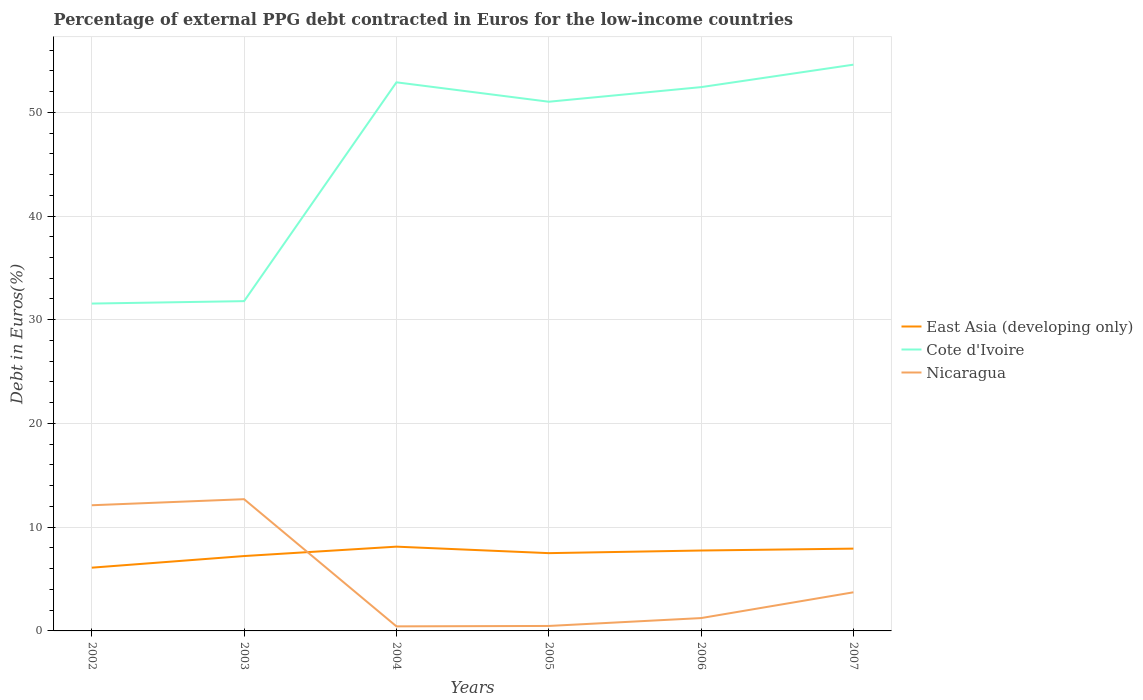Across all years, what is the maximum percentage of external PPG debt contracted in Euros in East Asia (developing only)?
Make the answer very short. 6.1. In which year was the percentage of external PPG debt contracted in Euros in Nicaragua maximum?
Make the answer very short. 2004. What is the total percentage of external PPG debt contracted in Euros in East Asia (developing only) in the graph?
Offer a very short reply. -2.03. What is the difference between the highest and the second highest percentage of external PPG debt contracted in Euros in East Asia (developing only)?
Your response must be concise. 2.03. What is the difference between the highest and the lowest percentage of external PPG debt contracted in Euros in East Asia (developing only)?
Offer a very short reply. 4. What is the difference between two consecutive major ticks on the Y-axis?
Offer a very short reply. 10. Does the graph contain any zero values?
Your answer should be compact. No. Does the graph contain grids?
Offer a very short reply. Yes. How are the legend labels stacked?
Give a very brief answer. Vertical. What is the title of the graph?
Offer a terse response. Percentage of external PPG debt contracted in Euros for the low-income countries. Does "Guinea-Bissau" appear as one of the legend labels in the graph?
Your response must be concise. No. What is the label or title of the X-axis?
Give a very brief answer. Years. What is the label or title of the Y-axis?
Your answer should be compact. Debt in Euros(%). What is the Debt in Euros(%) in East Asia (developing only) in 2002?
Offer a terse response. 6.1. What is the Debt in Euros(%) of Cote d'Ivoire in 2002?
Offer a terse response. 31.56. What is the Debt in Euros(%) of Nicaragua in 2002?
Provide a short and direct response. 12.12. What is the Debt in Euros(%) in East Asia (developing only) in 2003?
Your answer should be compact. 7.22. What is the Debt in Euros(%) of Cote d'Ivoire in 2003?
Offer a terse response. 31.79. What is the Debt in Euros(%) of Nicaragua in 2003?
Offer a terse response. 12.7. What is the Debt in Euros(%) of East Asia (developing only) in 2004?
Give a very brief answer. 8.12. What is the Debt in Euros(%) of Cote d'Ivoire in 2004?
Provide a succinct answer. 52.89. What is the Debt in Euros(%) in Nicaragua in 2004?
Your response must be concise. 0.44. What is the Debt in Euros(%) of East Asia (developing only) in 2005?
Provide a succinct answer. 7.5. What is the Debt in Euros(%) of Cote d'Ivoire in 2005?
Keep it short and to the point. 51.02. What is the Debt in Euros(%) of Nicaragua in 2005?
Offer a very short reply. 0.48. What is the Debt in Euros(%) in East Asia (developing only) in 2006?
Provide a succinct answer. 7.75. What is the Debt in Euros(%) in Cote d'Ivoire in 2006?
Offer a terse response. 52.42. What is the Debt in Euros(%) in Nicaragua in 2006?
Offer a very short reply. 1.24. What is the Debt in Euros(%) of East Asia (developing only) in 2007?
Your answer should be compact. 7.93. What is the Debt in Euros(%) in Cote d'Ivoire in 2007?
Your answer should be compact. 54.59. What is the Debt in Euros(%) in Nicaragua in 2007?
Offer a terse response. 3.72. Across all years, what is the maximum Debt in Euros(%) of East Asia (developing only)?
Provide a short and direct response. 8.12. Across all years, what is the maximum Debt in Euros(%) in Cote d'Ivoire?
Offer a very short reply. 54.59. Across all years, what is the maximum Debt in Euros(%) of Nicaragua?
Keep it short and to the point. 12.7. Across all years, what is the minimum Debt in Euros(%) of East Asia (developing only)?
Provide a short and direct response. 6.1. Across all years, what is the minimum Debt in Euros(%) of Cote d'Ivoire?
Make the answer very short. 31.56. Across all years, what is the minimum Debt in Euros(%) of Nicaragua?
Offer a terse response. 0.44. What is the total Debt in Euros(%) in East Asia (developing only) in the graph?
Give a very brief answer. 44.62. What is the total Debt in Euros(%) of Cote d'Ivoire in the graph?
Ensure brevity in your answer.  274.27. What is the total Debt in Euros(%) in Nicaragua in the graph?
Provide a short and direct response. 30.7. What is the difference between the Debt in Euros(%) of East Asia (developing only) in 2002 and that in 2003?
Your answer should be compact. -1.12. What is the difference between the Debt in Euros(%) of Cote d'Ivoire in 2002 and that in 2003?
Give a very brief answer. -0.23. What is the difference between the Debt in Euros(%) in Nicaragua in 2002 and that in 2003?
Your answer should be compact. -0.58. What is the difference between the Debt in Euros(%) in East Asia (developing only) in 2002 and that in 2004?
Provide a succinct answer. -2.03. What is the difference between the Debt in Euros(%) in Cote d'Ivoire in 2002 and that in 2004?
Keep it short and to the point. -21.33. What is the difference between the Debt in Euros(%) in Nicaragua in 2002 and that in 2004?
Provide a succinct answer. 11.68. What is the difference between the Debt in Euros(%) of East Asia (developing only) in 2002 and that in 2005?
Ensure brevity in your answer.  -1.4. What is the difference between the Debt in Euros(%) in Cote d'Ivoire in 2002 and that in 2005?
Offer a very short reply. -19.46. What is the difference between the Debt in Euros(%) of Nicaragua in 2002 and that in 2005?
Offer a terse response. 11.64. What is the difference between the Debt in Euros(%) of East Asia (developing only) in 2002 and that in 2006?
Provide a succinct answer. -1.65. What is the difference between the Debt in Euros(%) in Cote d'Ivoire in 2002 and that in 2006?
Ensure brevity in your answer.  -20.87. What is the difference between the Debt in Euros(%) of Nicaragua in 2002 and that in 2006?
Keep it short and to the point. 10.88. What is the difference between the Debt in Euros(%) in East Asia (developing only) in 2002 and that in 2007?
Your answer should be very brief. -1.84. What is the difference between the Debt in Euros(%) in Cote d'Ivoire in 2002 and that in 2007?
Offer a very short reply. -23.03. What is the difference between the Debt in Euros(%) of Nicaragua in 2002 and that in 2007?
Keep it short and to the point. 8.39. What is the difference between the Debt in Euros(%) in East Asia (developing only) in 2003 and that in 2004?
Your answer should be very brief. -0.91. What is the difference between the Debt in Euros(%) in Cote d'Ivoire in 2003 and that in 2004?
Make the answer very short. -21.09. What is the difference between the Debt in Euros(%) of Nicaragua in 2003 and that in 2004?
Your answer should be very brief. 12.26. What is the difference between the Debt in Euros(%) of East Asia (developing only) in 2003 and that in 2005?
Provide a succinct answer. -0.28. What is the difference between the Debt in Euros(%) of Cote d'Ivoire in 2003 and that in 2005?
Provide a succinct answer. -19.22. What is the difference between the Debt in Euros(%) in Nicaragua in 2003 and that in 2005?
Your response must be concise. 12.22. What is the difference between the Debt in Euros(%) in East Asia (developing only) in 2003 and that in 2006?
Your answer should be compact. -0.53. What is the difference between the Debt in Euros(%) of Cote d'Ivoire in 2003 and that in 2006?
Offer a terse response. -20.63. What is the difference between the Debt in Euros(%) in Nicaragua in 2003 and that in 2006?
Keep it short and to the point. 11.46. What is the difference between the Debt in Euros(%) of East Asia (developing only) in 2003 and that in 2007?
Your answer should be very brief. -0.71. What is the difference between the Debt in Euros(%) in Cote d'Ivoire in 2003 and that in 2007?
Your answer should be compact. -22.8. What is the difference between the Debt in Euros(%) in Nicaragua in 2003 and that in 2007?
Your answer should be very brief. 8.98. What is the difference between the Debt in Euros(%) in East Asia (developing only) in 2004 and that in 2005?
Provide a succinct answer. 0.63. What is the difference between the Debt in Euros(%) in Cote d'Ivoire in 2004 and that in 2005?
Keep it short and to the point. 1.87. What is the difference between the Debt in Euros(%) of Nicaragua in 2004 and that in 2005?
Keep it short and to the point. -0.04. What is the difference between the Debt in Euros(%) in East Asia (developing only) in 2004 and that in 2006?
Provide a succinct answer. 0.37. What is the difference between the Debt in Euros(%) in Cote d'Ivoire in 2004 and that in 2006?
Your response must be concise. 0.46. What is the difference between the Debt in Euros(%) in Nicaragua in 2004 and that in 2006?
Keep it short and to the point. -0.8. What is the difference between the Debt in Euros(%) of East Asia (developing only) in 2004 and that in 2007?
Make the answer very short. 0.19. What is the difference between the Debt in Euros(%) of Cote d'Ivoire in 2004 and that in 2007?
Give a very brief answer. -1.7. What is the difference between the Debt in Euros(%) of Nicaragua in 2004 and that in 2007?
Your answer should be very brief. -3.28. What is the difference between the Debt in Euros(%) in East Asia (developing only) in 2005 and that in 2006?
Ensure brevity in your answer.  -0.25. What is the difference between the Debt in Euros(%) of Cote d'Ivoire in 2005 and that in 2006?
Offer a very short reply. -1.41. What is the difference between the Debt in Euros(%) of Nicaragua in 2005 and that in 2006?
Your answer should be compact. -0.76. What is the difference between the Debt in Euros(%) of East Asia (developing only) in 2005 and that in 2007?
Keep it short and to the point. -0.44. What is the difference between the Debt in Euros(%) in Cote d'Ivoire in 2005 and that in 2007?
Your answer should be very brief. -3.57. What is the difference between the Debt in Euros(%) of Nicaragua in 2005 and that in 2007?
Make the answer very short. -3.24. What is the difference between the Debt in Euros(%) of East Asia (developing only) in 2006 and that in 2007?
Ensure brevity in your answer.  -0.18. What is the difference between the Debt in Euros(%) of Cote d'Ivoire in 2006 and that in 2007?
Provide a short and direct response. -2.17. What is the difference between the Debt in Euros(%) of Nicaragua in 2006 and that in 2007?
Offer a terse response. -2.49. What is the difference between the Debt in Euros(%) in East Asia (developing only) in 2002 and the Debt in Euros(%) in Cote d'Ivoire in 2003?
Ensure brevity in your answer.  -25.69. What is the difference between the Debt in Euros(%) of East Asia (developing only) in 2002 and the Debt in Euros(%) of Nicaragua in 2003?
Provide a succinct answer. -6.6. What is the difference between the Debt in Euros(%) in Cote d'Ivoire in 2002 and the Debt in Euros(%) in Nicaragua in 2003?
Make the answer very short. 18.86. What is the difference between the Debt in Euros(%) in East Asia (developing only) in 2002 and the Debt in Euros(%) in Cote d'Ivoire in 2004?
Provide a short and direct response. -46.79. What is the difference between the Debt in Euros(%) in East Asia (developing only) in 2002 and the Debt in Euros(%) in Nicaragua in 2004?
Your answer should be very brief. 5.66. What is the difference between the Debt in Euros(%) in Cote d'Ivoire in 2002 and the Debt in Euros(%) in Nicaragua in 2004?
Provide a short and direct response. 31.12. What is the difference between the Debt in Euros(%) of East Asia (developing only) in 2002 and the Debt in Euros(%) of Cote d'Ivoire in 2005?
Provide a succinct answer. -44.92. What is the difference between the Debt in Euros(%) of East Asia (developing only) in 2002 and the Debt in Euros(%) of Nicaragua in 2005?
Your response must be concise. 5.62. What is the difference between the Debt in Euros(%) in Cote d'Ivoire in 2002 and the Debt in Euros(%) in Nicaragua in 2005?
Provide a short and direct response. 31.08. What is the difference between the Debt in Euros(%) of East Asia (developing only) in 2002 and the Debt in Euros(%) of Cote d'Ivoire in 2006?
Your response must be concise. -46.33. What is the difference between the Debt in Euros(%) of East Asia (developing only) in 2002 and the Debt in Euros(%) of Nicaragua in 2006?
Offer a terse response. 4.86. What is the difference between the Debt in Euros(%) of Cote d'Ivoire in 2002 and the Debt in Euros(%) of Nicaragua in 2006?
Provide a succinct answer. 30.32. What is the difference between the Debt in Euros(%) of East Asia (developing only) in 2002 and the Debt in Euros(%) of Cote d'Ivoire in 2007?
Keep it short and to the point. -48.49. What is the difference between the Debt in Euros(%) of East Asia (developing only) in 2002 and the Debt in Euros(%) of Nicaragua in 2007?
Provide a short and direct response. 2.37. What is the difference between the Debt in Euros(%) of Cote d'Ivoire in 2002 and the Debt in Euros(%) of Nicaragua in 2007?
Provide a succinct answer. 27.83. What is the difference between the Debt in Euros(%) in East Asia (developing only) in 2003 and the Debt in Euros(%) in Cote d'Ivoire in 2004?
Your answer should be very brief. -45.67. What is the difference between the Debt in Euros(%) in East Asia (developing only) in 2003 and the Debt in Euros(%) in Nicaragua in 2004?
Your answer should be compact. 6.78. What is the difference between the Debt in Euros(%) of Cote d'Ivoire in 2003 and the Debt in Euros(%) of Nicaragua in 2004?
Your answer should be very brief. 31.35. What is the difference between the Debt in Euros(%) of East Asia (developing only) in 2003 and the Debt in Euros(%) of Cote d'Ivoire in 2005?
Your response must be concise. -43.8. What is the difference between the Debt in Euros(%) of East Asia (developing only) in 2003 and the Debt in Euros(%) of Nicaragua in 2005?
Offer a terse response. 6.74. What is the difference between the Debt in Euros(%) in Cote d'Ivoire in 2003 and the Debt in Euros(%) in Nicaragua in 2005?
Make the answer very short. 31.31. What is the difference between the Debt in Euros(%) in East Asia (developing only) in 2003 and the Debt in Euros(%) in Cote d'Ivoire in 2006?
Your answer should be compact. -45.21. What is the difference between the Debt in Euros(%) in East Asia (developing only) in 2003 and the Debt in Euros(%) in Nicaragua in 2006?
Ensure brevity in your answer.  5.98. What is the difference between the Debt in Euros(%) of Cote d'Ivoire in 2003 and the Debt in Euros(%) of Nicaragua in 2006?
Make the answer very short. 30.55. What is the difference between the Debt in Euros(%) of East Asia (developing only) in 2003 and the Debt in Euros(%) of Cote d'Ivoire in 2007?
Offer a very short reply. -47.37. What is the difference between the Debt in Euros(%) of East Asia (developing only) in 2003 and the Debt in Euros(%) of Nicaragua in 2007?
Offer a very short reply. 3.49. What is the difference between the Debt in Euros(%) of Cote d'Ivoire in 2003 and the Debt in Euros(%) of Nicaragua in 2007?
Ensure brevity in your answer.  28.07. What is the difference between the Debt in Euros(%) of East Asia (developing only) in 2004 and the Debt in Euros(%) of Cote d'Ivoire in 2005?
Keep it short and to the point. -42.89. What is the difference between the Debt in Euros(%) in East Asia (developing only) in 2004 and the Debt in Euros(%) in Nicaragua in 2005?
Your answer should be compact. 7.64. What is the difference between the Debt in Euros(%) of Cote d'Ivoire in 2004 and the Debt in Euros(%) of Nicaragua in 2005?
Offer a terse response. 52.41. What is the difference between the Debt in Euros(%) of East Asia (developing only) in 2004 and the Debt in Euros(%) of Cote d'Ivoire in 2006?
Ensure brevity in your answer.  -44.3. What is the difference between the Debt in Euros(%) in East Asia (developing only) in 2004 and the Debt in Euros(%) in Nicaragua in 2006?
Provide a short and direct response. 6.89. What is the difference between the Debt in Euros(%) of Cote d'Ivoire in 2004 and the Debt in Euros(%) of Nicaragua in 2006?
Give a very brief answer. 51.65. What is the difference between the Debt in Euros(%) of East Asia (developing only) in 2004 and the Debt in Euros(%) of Cote d'Ivoire in 2007?
Your response must be concise. -46.47. What is the difference between the Debt in Euros(%) in East Asia (developing only) in 2004 and the Debt in Euros(%) in Nicaragua in 2007?
Ensure brevity in your answer.  4.4. What is the difference between the Debt in Euros(%) of Cote d'Ivoire in 2004 and the Debt in Euros(%) of Nicaragua in 2007?
Ensure brevity in your answer.  49.16. What is the difference between the Debt in Euros(%) of East Asia (developing only) in 2005 and the Debt in Euros(%) of Cote d'Ivoire in 2006?
Provide a short and direct response. -44.93. What is the difference between the Debt in Euros(%) in East Asia (developing only) in 2005 and the Debt in Euros(%) in Nicaragua in 2006?
Give a very brief answer. 6.26. What is the difference between the Debt in Euros(%) in Cote d'Ivoire in 2005 and the Debt in Euros(%) in Nicaragua in 2006?
Offer a very short reply. 49.78. What is the difference between the Debt in Euros(%) in East Asia (developing only) in 2005 and the Debt in Euros(%) in Cote d'Ivoire in 2007?
Provide a succinct answer. -47.09. What is the difference between the Debt in Euros(%) of East Asia (developing only) in 2005 and the Debt in Euros(%) of Nicaragua in 2007?
Your response must be concise. 3.77. What is the difference between the Debt in Euros(%) of Cote d'Ivoire in 2005 and the Debt in Euros(%) of Nicaragua in 2007?
Provide a short and direct response. 47.29. What is the difference between the Debt in Euros(%) of East Asia (developing only) in 2006 and the Debt in Euros(%) of Cote d'Ivoire in 2007?
Provide a short and direct response. -46.84. What is the difference between the Debt in Euros(%) in East Asia (developing only) in 2006 and the Debt in Euros(%) in Nicaragua in 2007?
Keep it short and to the point. 4.03. What is the difference between the Debt in Euros(%) in Cote d'Ivoire in 2006 and the Debt in Euros(%) in Nicaragua in 2007?
Give a very brief answer. 48.7. What is the average Debt in Euros(%) of East Asia (developing only) per year?
Offer a very short reply. 7.44. What is the average Debt in Euros(%) in Cote d'Ivoire per year?
Make the answer very short. 45.71. What is the average Debt in Euros(%) in Nicaragua per year?
Keep it short and to the point. 5.12. In the year 2002, what is the difference between the Debt in Euros(%) of East Asia (developing only) and Debt in Euros(%) of Cote d'Ivoire?
Your answer should be very brief. -25.46. In the year 2002, what is the difference between the Debt in Euros(%) in East Asia (developing only) and Debt in Euros(%) in Nicaragua?
Keep it short and to the point. -6.02. In the year 2002, what is the difference between the Debt in Euros(%) in Cote d'Ivoire and Debt in Euros(%) in Nicaragua?
Ensure brevity in your answer.  19.44. In the year 2003, what is the difference between the Debt in Euros(%) in East Asia (developing only) and Debt in Euros(%) in Cote d'Ivoire?
Your response must be concise. -24.57. In the year 2003, what is the difference between the Debt in Euros(%) in East Asia (developing only) and Debt in Euros(%) in Nicaragua?
Offer a very short reply. -5.48. In the year 2003, what is the difference between the Debt in Euros(%) in Cote d'Ivoire and Debt in Euros(%) in Nicaragua?
Offer a very short reply. 19.09. In the year 2004, what is the difference between the Debt in Euros(%) of East Asia (developing only) and Debt in Euros(%) of Cote d'Ivoire?
Make the answer very short. -44.76. In the year 2004, what is the difference between the Debt in Euros(%) of East Asia (developing only) and Debt in Euros(%) of Nicaragua?
Provide a short and direct response. 7.68. In the year 2004, what is the difference between the Debt in Euros(%) of Cote d'Ivoire and Debt in Euros(%) of Nicaragua?
Your answer should be compact. 52.45. In the year 2005, what is the difference between the Debt in Euros(%) of East Asia (developing only) and Debt in Euros(%) of Cote d'Ivoire?
Your answer should be very brief. -43.52. In the year 2005, what is the difference between the Debt in Euros(%) in East Asia (developing only) and Debt in Euros(%) in Nicaragua?
Your response must be concise. 7.02. In the year 2005, what is the difference between the Debt in Euros(%) of Cote d'Ivoire and Debt in Euros(%) of Nicaragua?
Your response must be concise. 50.54. In the year 2006, what is the difference between the Debt in Euros(%) of East Asia (developing only) and Debt in Euros(%) of Cote d'Ivoire?
Give a very brief answer. -44.67. In the year 2006, what is the difference between the Debt in Euros(%) in East Asia (developing only) and Debt in Euros(%) in Nicaragua?
Ensure brevity in your answer.  6.51. In the year 2006, what is the difference between the Debt in Euros(%) of Cote d'Ivoire and Debt in Euros(%) of Nicaragua?
Your answer should be very brief. 51.19. In the year 2007, what is the difference between the Debt in Euros(%) of East Asia (developing only) and Debt in Euros(%) of Cote d'Ivoire?
Ensure brevity in your answer.  -46.66. In the year 2007, what is the difference between the Debt in Euros(%) in East Asia (developing only) and Debt in Euros(%) in Nicaragua?
Provide a succinct answer. 4.21. In the year 2007, what is the difference between the Debt in Euros(%) in Cote d'Ivoire and Debt in Euros(%) in Nicaragua?
Provide a succinct answer. 50.87. What is the ratio of the Debt in Euros(%) of East Asia (developing only) in 2002 to that in 2003?
Ensure brevity in your answer.  0.84. What is the ratio of the Debt in Euros(%) of Nicaragua in 2002 to that in 2003?
Ensure brevity in your answer.  0.95. What is the ratio of the Debt in Euros(%) in East Asia (developing only) in 2002 to that in 2004?
Provide a short and direct response. 0.75. What is the ratio of the Debt in Euros(%) of Cote d'Ivoire in 2002 to that in 2004?
Ensure brevity in your answer.  0.6. What is the ratio of the Debt in Euros(%) in Nicaragua in 2002 to that in 2004?
Keep it short and to the point. 27.52. What is the ratio of the Debt in Euros(%) of East Asia (developing only) in 2002 to that in 2005?
Give a very brief answer. 0.81. What is the ratio of the Debt in Euros(%) of Cote d'Ivoire in 2002 to that in 2005?
Offer a very short reply. 0.62. What is the ratio of the Debt in Euros(%) of Nicaragua in 2002 to that in 2005?
Your response must be concise. 25.29. What is the ratio of the Debt in Euros(%) in East Asia (developing only) in 2002 to that in 2006?
Offer a terse response. 0.79. What is the ratio of the Debt in Euros(%) of Cote d'Ivoire in 2002 to that in 2006?
Your answer should be very brief. 0.6. What is the ratio of the Debt in Euros(%) in Nicaragua in 2002 to that in 2006?
Give a very brief answer. 9.78. What is the ratio of the Debt in Euros(%) of East Asia (developing only) in 2002 to that in 2007?
Keep it short and to the point. 0.77. What is the ratio of the Debt in Euros(%) in Cote d'Ivoire in 2002 to that in 2007?
Offer a terse response. 0.58. What is the ratio of the Debt in Euros(%) in Nicaragua in 2002 to that in 2007?
Your response must be concise. 3.25. What is the ratio of the Debt in Euros(%) of East Asia (developing only) in 2003 to that in 2004?
Keep it short and to the point. 0.89. What is the ratio of the Debt in Euros(%) of Cote d'Ivoire in 2003 to that in 2004?
Your response must be concise. 0.6. What is the ratio of the Debt in Euros(%) of Nicaragua in 2003 to that in 2004?
Your answer should be compact. 28.85. What is the ratio of the Debt in Euros(%) in East Asia (developing only) in 2003 to that in 2005?
Your answer should be compact. 0.96. What is the ratio of the Debt in Euros(%) in Cote d'Ivoire in 2003 to that in 2005?
Your answer should be very brief. 0.62. What is the ratio of the Debt in Euros(%) in Nicaragua in 2003 to that in 2005?
Your answer should be very brief. 26.51. What is the ratio of the Debt in Euros(%) of East Asia (developing only) in 2003 to that in 2006?
Offer a very short reply. 0.93. What is the ratio of the Debt in Euros(%) of Cote d'Ivoire in 2003 to that in 2006?
Your answer should be compact. 0.61. What is the ratio of the Debt in Euros(%) of Nicaragua in 2003 to that in 2006?
Keep it short and to the point. 10.26. What is the ratio of the Debt in Euros(%) in East Asia (developing only) in 2003 to that in 2007?
Provide a short and direct response. 0.91. What is the ratio of the Debt in Euros(%) of Cote d'Ivoire in 2003 to that in 2007?
Ensure brevity in your answer.  0.58. What is the ratio of the Debt in Euros(%) of Nicaragua in 2003 to that in 2007?
Offer a very short reply. 3.41. What is the ratio of the Debt in Euros(%) in East Asia (developing only) in 2004 to that in 2005?
Provide a short and direct response. 1.08. What is the ratio of the Debt in Euros(%) in Cote d'Ivoire in 2004 to that in 2005?
Provide a short and direct response. 1.04. What is the ratio of the Debt in Euros(%) of Nicaragua in 2004 to that in 2005?
Make the answer very short. 0.92. What is the ratio of the Debt in Euros(%) of East Asia (developing only) in 2004 to that in 2006?
Give a very brief answer. 1.05. What is the ratio of the Debt in Euros(%) of Cote d'Ivoire in 2004 to that in 2006?
Ensure brevity in your answer.  1.01. What is the ratio of the Debt in Euros(%) in Nicaragua in 2004 to that in 2006?
Your answer should be very brief. 0.36. What is the ratio of the Debt in Euros(%) of East Asia (developing only) in 2004 to that in 2007?
Keep it short and to the point. 1.02. What is the ratio of the Debt in Euros(%) in Cote d'Ivoire in 2004 to that in 2007?
Offer a very short reply. 0.97. What is the ratio of the Debt in Euros(%) in Nicaragua in 2004 to that in 2007?
Make the answer very short. 0.12. What is the ratio of the Debt in Euros(%) in East Asia (developing only) in 2005 to that in 2006?
Offer a very short reply. 0.97. What is the ratio of the Debt in Euros(%) of Cote d'Ivoire in 2005 to that in 2006?
Ensure brevity in your answer.  0.97. What is the ratio of the Debt in Euros(%) in Nicaragua in 2005 to that in 2006?
Provide a succinct answer. 0.39. What is the ratio of the Debt in Euros(%) in East Asia (developing only) in 2005 to that in 2007?
Your response must be concise. 0.95. What is the ratio of the Debt in Euros(%) of Cote d'Ivoire in 2005 to that in 2007?
Offer a very short reply. 0.93. What is the ratio of the Debt in Euros(%) in Nicaragua in 2005 to that in 2007?
Offer a very short reply. 0.13. What is the ratio of the Debt in Euros(%) of East Asia (developing only) in 2006 to that in 2007?
Give a very brief answer. 0.98. What is the ratio of the Debt in Euros(%) of Cote d'Ivoire in 2006 to that in 2007?
Provide a succinct answer. 0.96. What is the ratio of the Debt in Euros(%) of Nicaragua in 2006 to that in 2007?
Keep it short and to the point. 0.33. What is the difference between the highest and the second highest Debt in Euros(%) in East Asia (developing only)?
Keep it short and to the point. 0.19. What is the difference between the highest and the second highest Debt in Euros(%) of Cote d'Ivoire?
Offer a terse response. 1.7. What is the difference between the highest and the second highest Debt in Euros(%) of Nicaragua?
Your answer should be compact. 0.58. What is the difference between the highest and the lowest Debt in Euros(%) of East Asia (developing only)?
Offer a very short reply. 2.03. What is the difference between the highest and the lowest Debt in Euros(%) in Cote d'Ivoire?
Your answer should be very brief. 23.03. What is the difference between the highest and the lowest Debt in Euros(%) of Nicaragua?
Offer a terse response. 12.26. 